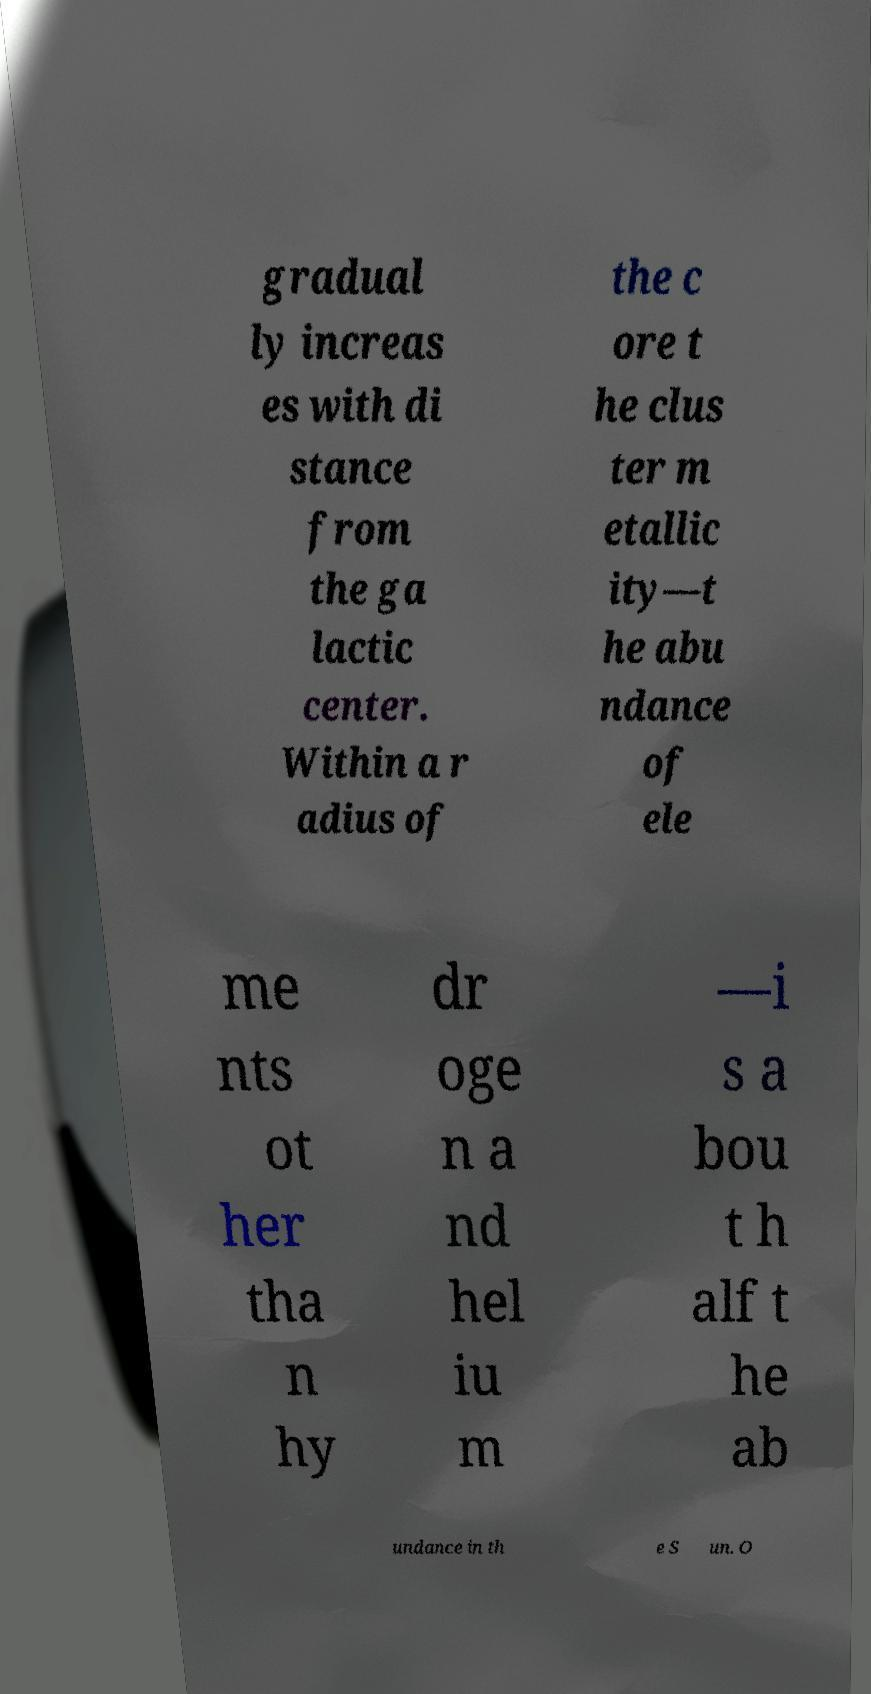For documentation purposes, I need the text within this image transcribed. Could you provide that? gradual ly increas es with di stance from the ga lactic center. Within a r adius of the c ore t he clus ter m etallic ity—t he abu ndance of ele me nts ot her tha n hy dr oge n a nd hel iu m —i s a bou t h alf t he ab undance in th e S un. O 